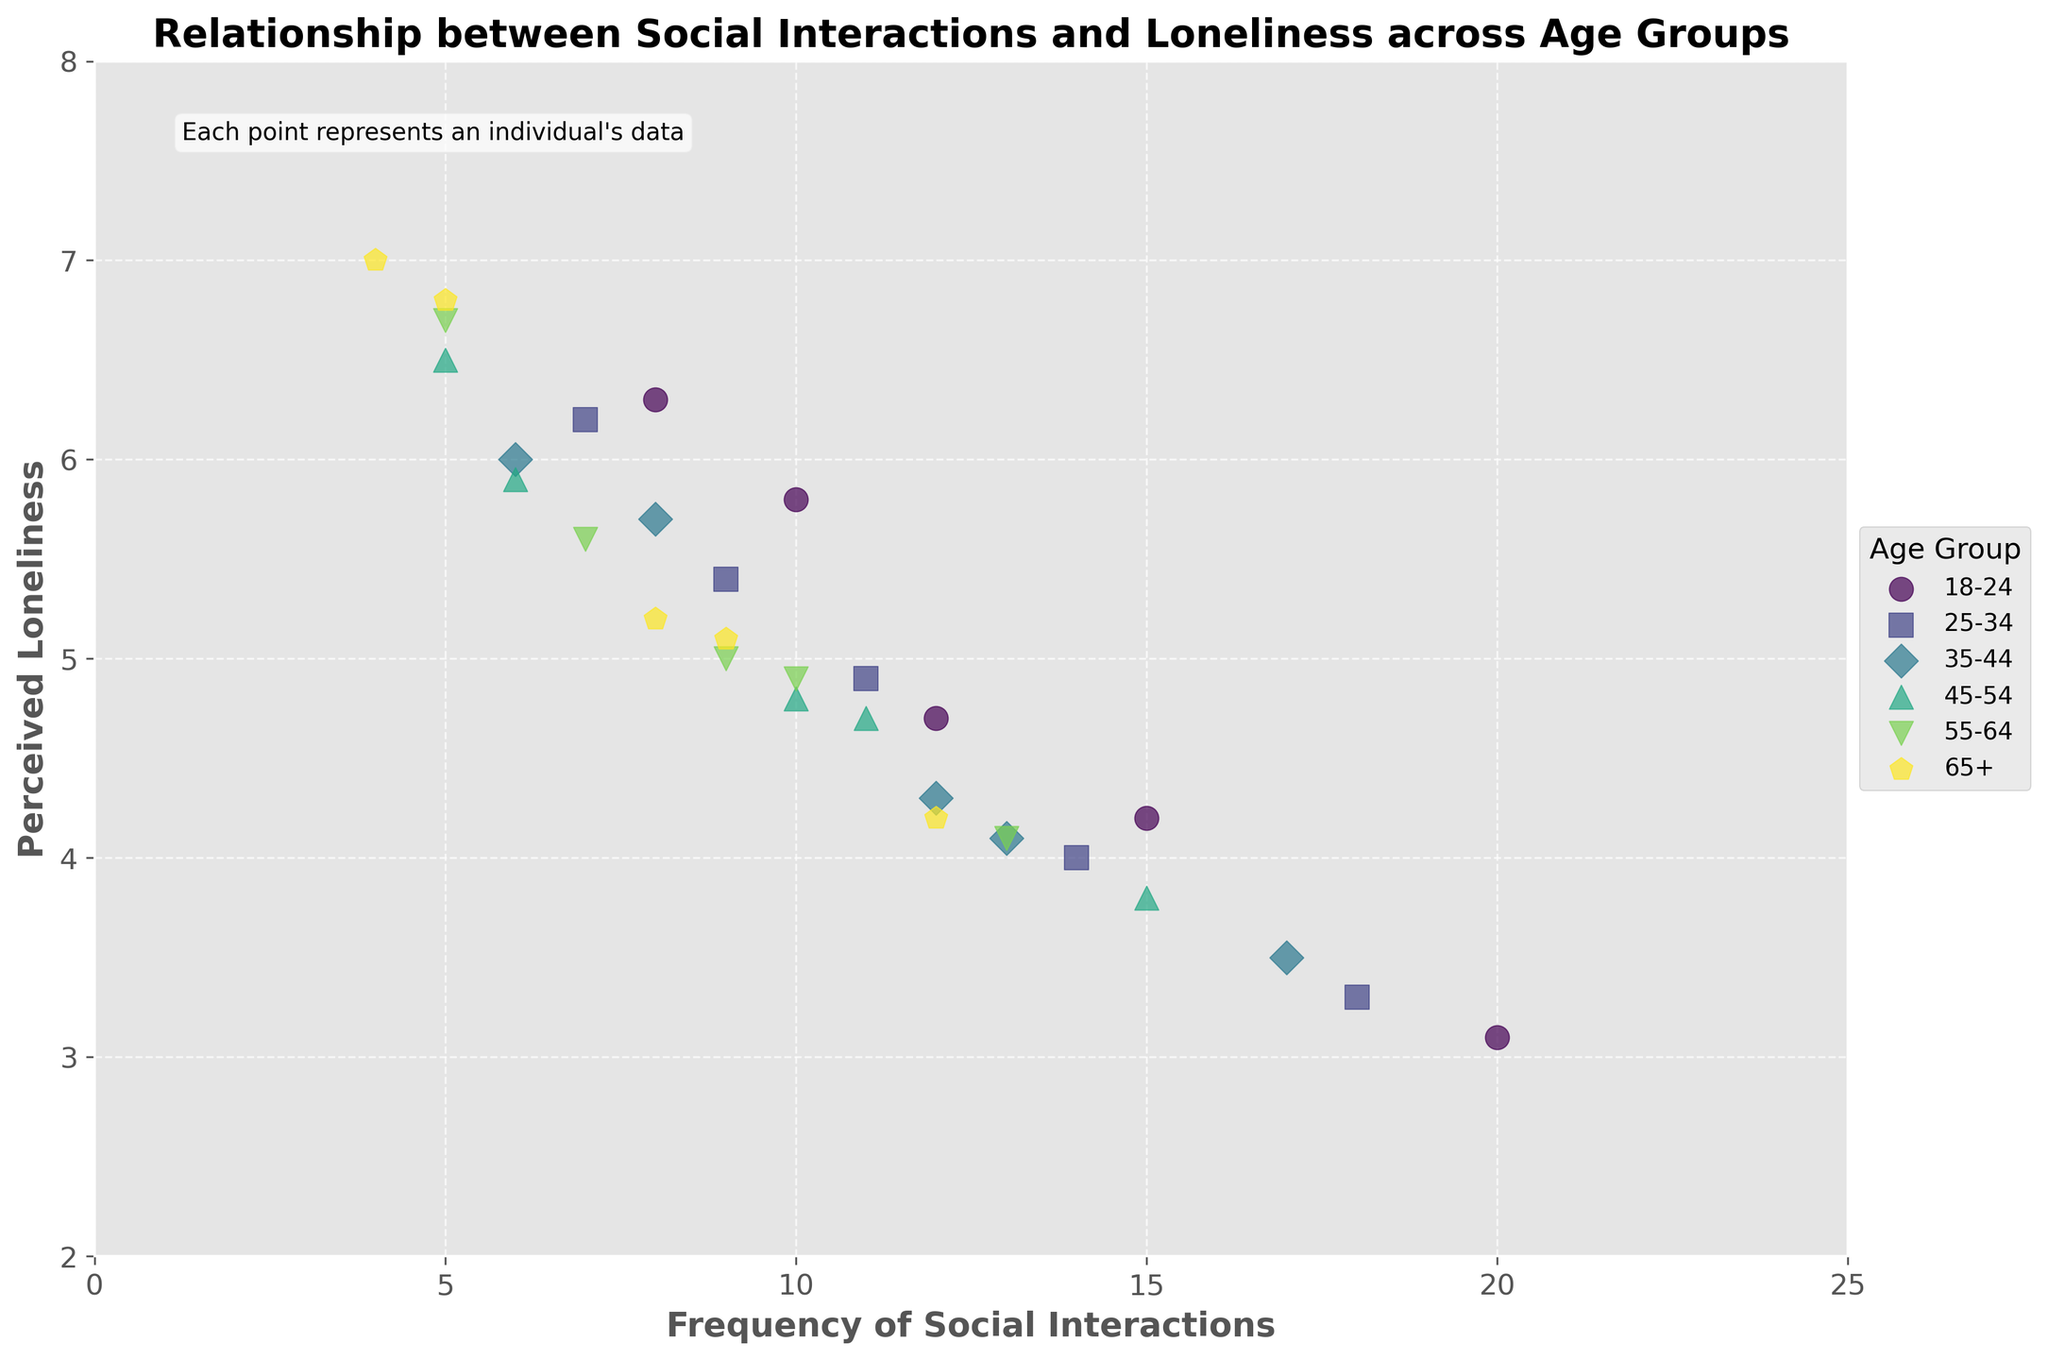what is the title of the plot? The title of the plot is usually found at the top of the figure. In this case, the title reads "Relationship between Social Interactions and Loneliness across Age Groups".
Answer: Relationship between Social Interactions and Loneliness across Age Groups What groups are present in the legend? The legend lists the age groups that are represented by different colors and markers. The groups present are 18-24, 25-34, 35-44, 45-54, 55-64, and 65+.
Answer: 18-24, 25-34, 35-44, 45-54, 55-64, 65+ Which data point represents the lowest perceived loneliness in the 35-44 age group? Look at the data points for the 35-44 age group. The lowest perceived loneliness value is 3.5 and the corresponding data point has a frequency of social interactions at 17.
Answer: 17, 3.5 How many unique colors are used in the scatter plot? Each age group is represented by a unique color. Identify the number of different colors which correspond to the number of unique age groups. There are 6 age groups.
Answer: 6 In the age group 55-64, what is the range of perceived loneliness? The perceived loneliness values for the 55-64 age group range from 4.1 to 6.7. The range is calculated as the difference between the maximum and the minimum values.
Answer: 2.6 Which age group has the most diverse frequency of social interactions? Compare the ranges of the frequency of social interactions for each age group. The age group with the largest range is the most diverse. The 18-24 group has a range from 8 to 20, which is the widest.
Answer: 18-24 Compare the perceived loneliness for individuals with 10 social interactions in age groups 18-24 and 45-54. Identify the perceived loneliness values for individuals with 10 social interactions in both age groups. For 18-24, it is 5.8, and for 45-54, it is 4.8. To compare, 5.8 is higher than 4.8.
Answer: 18-24 has higher perceived loneliness than 45-54 What is the overall trend between frequency of social interactions and perceived loneliness across all age groups? Check the general direction in which the data points move. As the frequency of social interactions increases, the perceived loneliness tends to decrease. This indicates a negative correlation.
Answer: Negative correlation Which age group shows a clear negative correlation between frequency of social interactions and perceived loneliness? Examine each age group's data points and their orientation. The 18-24 age group shows a clear trend where higher social interactions correspond to lower perceived loneliness.
Answer: 18-24 